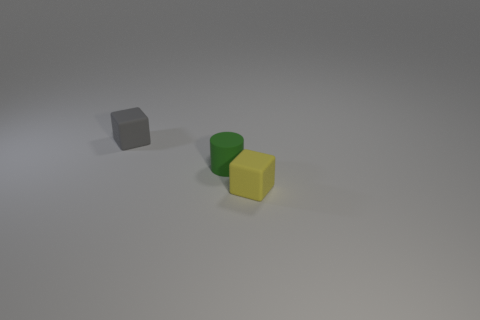Is the shape of the tiny rubber thing that is to the right of the small green object the same as  the tiny gray object?
Ensure brevity in your answer.  Yes. How many other things are the same shape as the tiny yellow thing?
Give a very brief answer. 1. There is a gray rubber thing that is behind the tiny yellow thing; what shape is it?
Ensure brevity in your answer.  Cube. Is there a tiny green object that has the same material as the yellow thing?
Offer a very short reply. Yes. Does the block to the left of the tiny cylinder have the same color as the cylinder?
Keep it short and to the point. No. How big is the yellow matte thing?
Provide a succinct answer. Small. There is a small block right of the small gray block left of the green rubber thing; is there a small rubber cylinder in front of it?
Provide a succinct answer. No. What number of small matte cubes are behind the gray rubber object?
Provide a succinct answer. 0. What number of other tiny rubber cylinders are the same color as the rubber cylinder?
Your response must be concise. 0. How many objects are either tiny things that are in front of the small green rubber thing or rubber cubes to the left of the green matte object?
Make the answer very short. 2. 